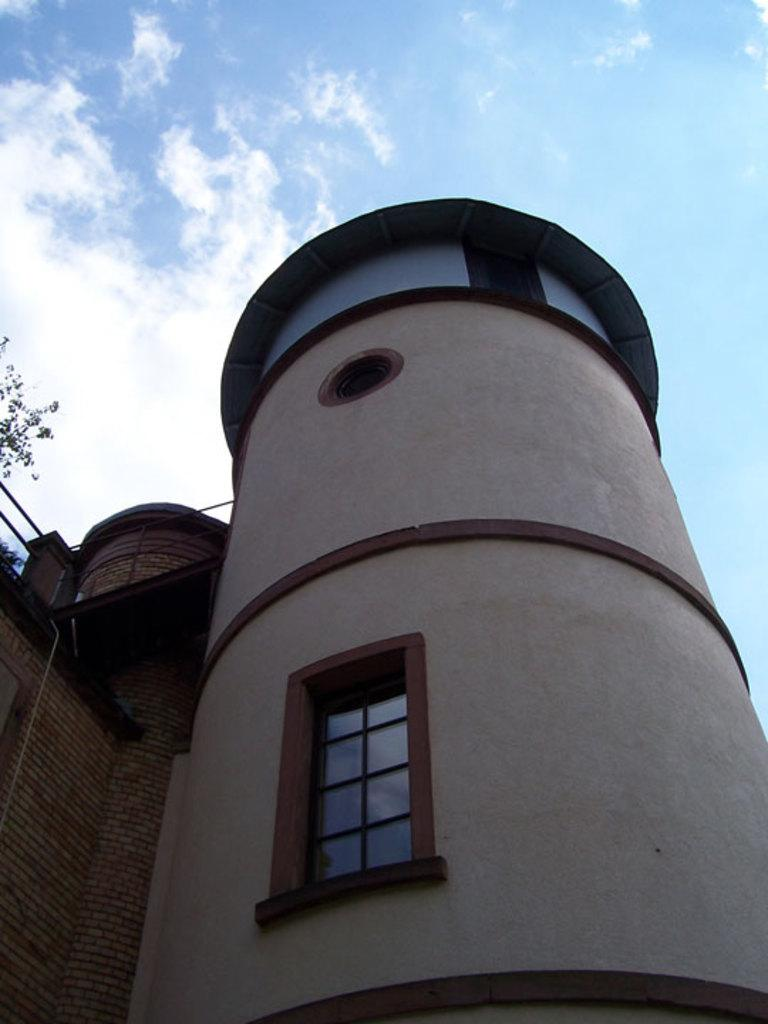What type of structure is visible in the image? There is a building with windows in the image. What natural element can be seen in the image? There is a tree in the image. What type of barrier is present in the image? There is a fence in the image. What is visible in the background of the image? The sky is visible in the image. What atmospheric feature can be seen in the sky? Clouds are present in the sky. What type of suit is hanging on the tree in the image? There is no suit hanging on the tree in the image; it only features a building, a tree, a fence, and the sky. What type of top is visible on the building in the image? The building in the image does not have a top; it is a single-story structure with windows. 